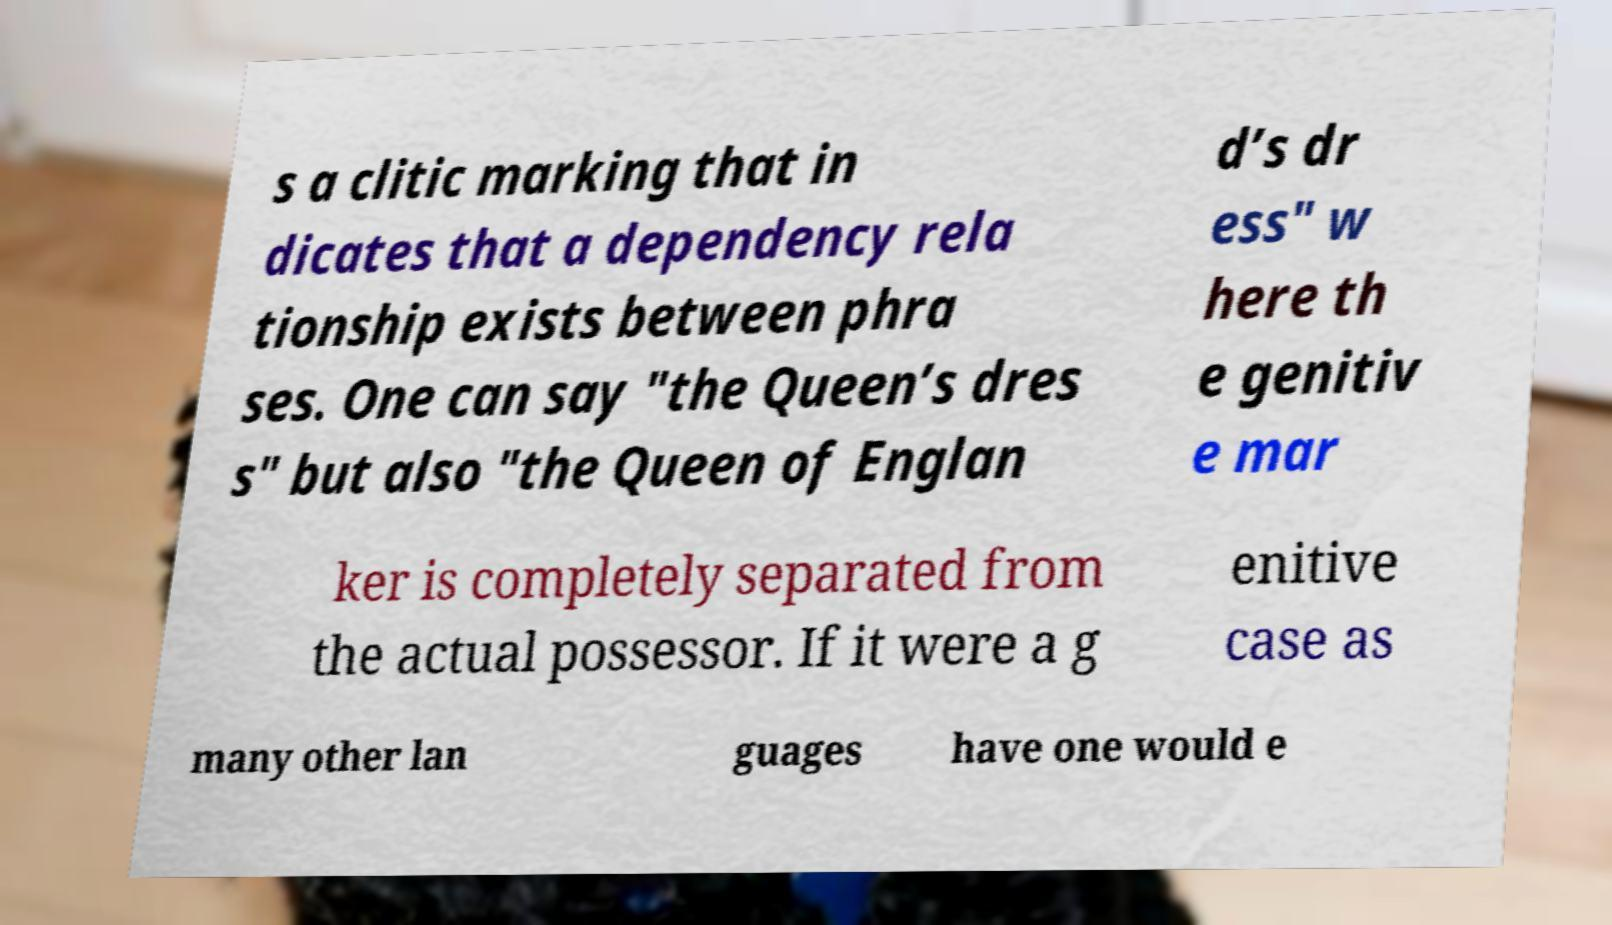Could you assist in decoding the text presented in this image and type it out clearly? s a clitic marking that in dicates that a dependency rela tionship exists between phra ses. One can say "the Queen’s dres s" but also "the Queen of Englan d’s dr ess" w here th e genitiv e mar ker is completely separated from the actual possessor. If it were a g enitive case as many other lan guages have one would e 